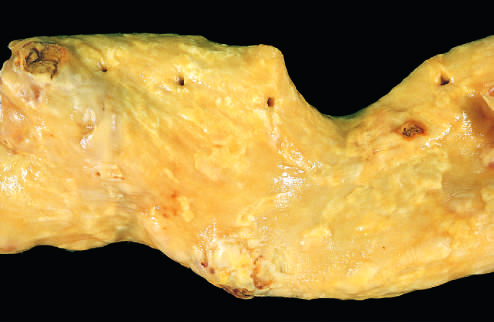what is composed of fibrous plaques?
Answer the question using a single word or phrase. Aorta with mild atherosclerosis 